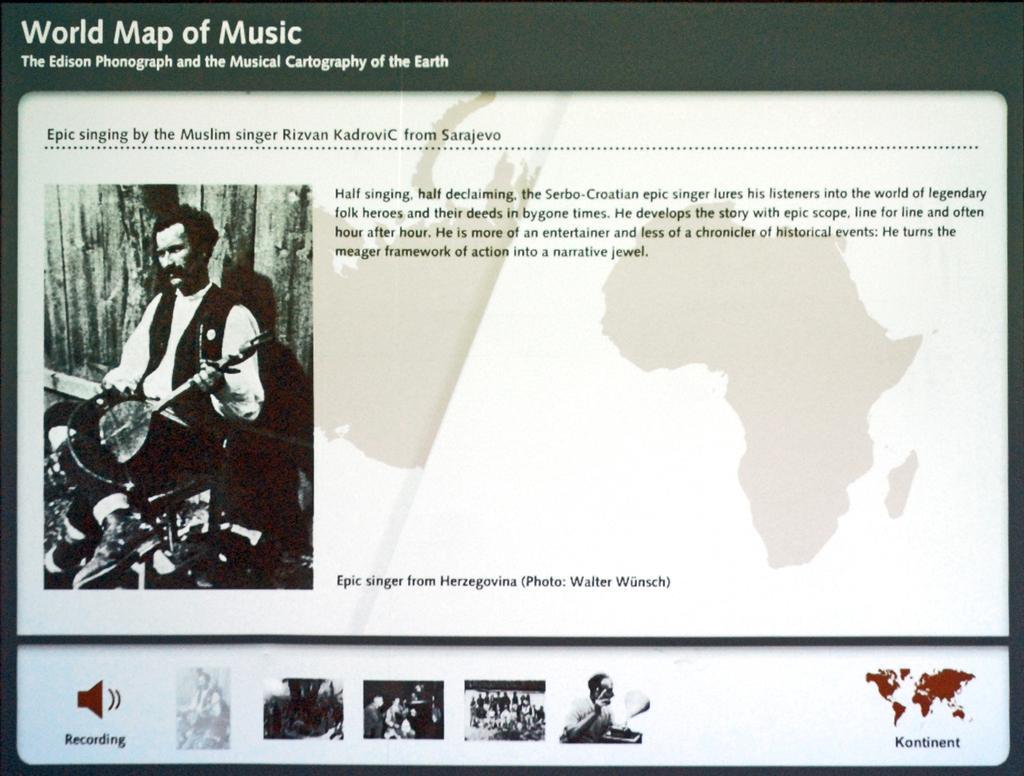Can you describe this image briefly? This picture consists of a poster, where there is an image of a man on the left side and there is a map, written content and other images. 